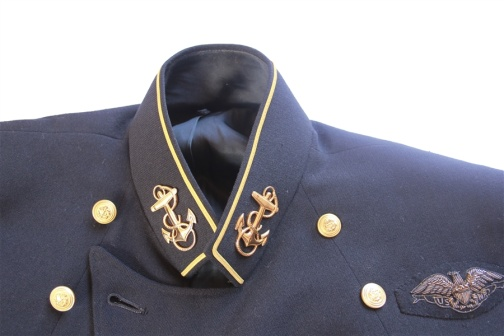Write a detailed description of the given image. The image showcases a close-up of a navy blue military jacket, which is richly adorned with various golden accents. The black collar of the jacket is finely outlined with gold piping, offering an elegant contrast. The most prominent decorations on the collar are two golden embroidered insignias that appear to be naval symbols, associated with maritime heritage. Golden buttons are symmetrically placed on the jacket, enhancing its regal appearance. On the right side of the jacket, a silver eagle emblem with outstretched wings is prominently displayed, symbolizing power and freedom. The jacket appears to be mounted on a mannequin or hanger, suggested by the black inner fabric visible at the collar. The arrangement of these elements and the meticulous craftsmanship reflect the discipline, prestige, and tradition of military attire. 